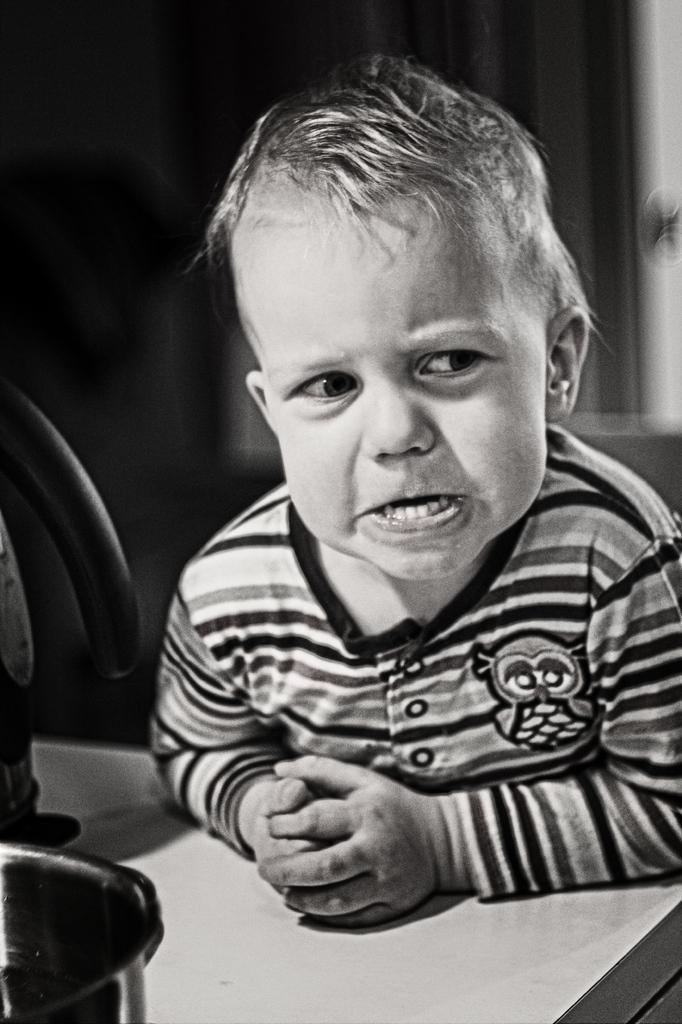What is the color scheme of the image? The image is black and white. Who or what is the main subject in the image? There is a kid in the image. What can be seen on the left side of the image? There are objects on the left side of the image. How would you describe the background of the image? The background of the image is blurred. What type of zipper can be seen on the mailbox in the image? There is no mailbox or zipper present in the image. Is the kid on a swing in the image? There is no swing visible in the image. 